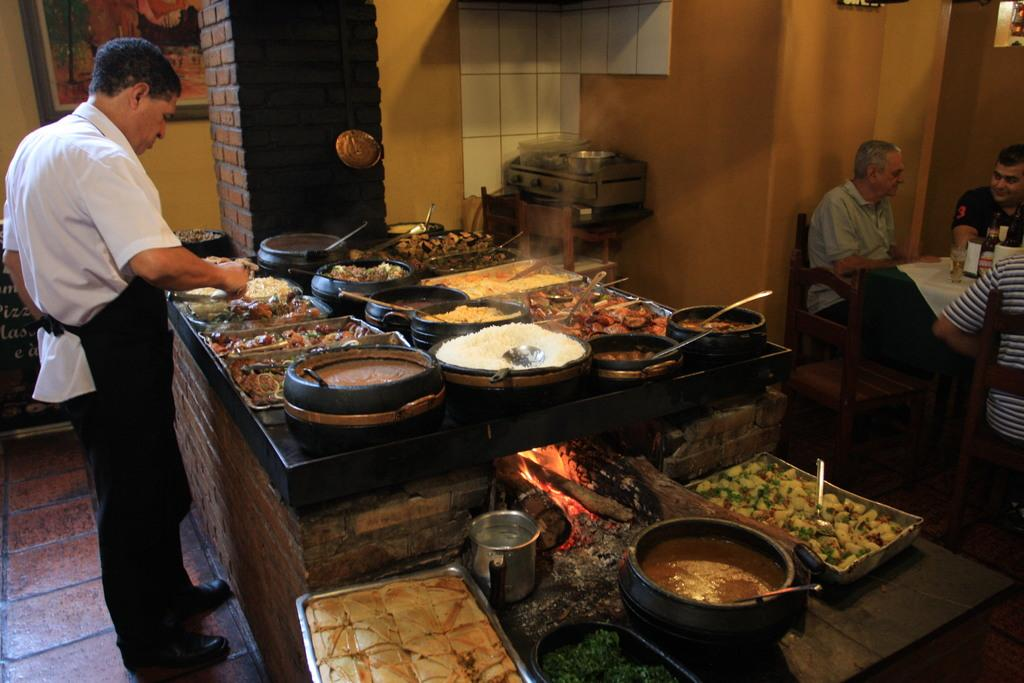What is the man in the image doing? The man is arranging dishes at a buffet. Where is the buffet located? The buffet is located in a restaurant. Can you describe the people in the image? There are people sitting at a table in the image. What holiday is being celebrated in the scene depicted in the image? There is no specific holiday mentioned or depicted in the image. 